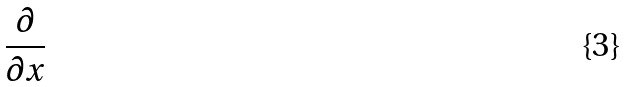Convert formula to latex. <formula><loc_0><loc_0><loc_500><loc_500>\frac { \partial } { \partial x }</formula> 